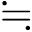<formula> <loc_0><loc_0><loc_500><loc_500>\ f a l l i n g d o t s e q</formula> 